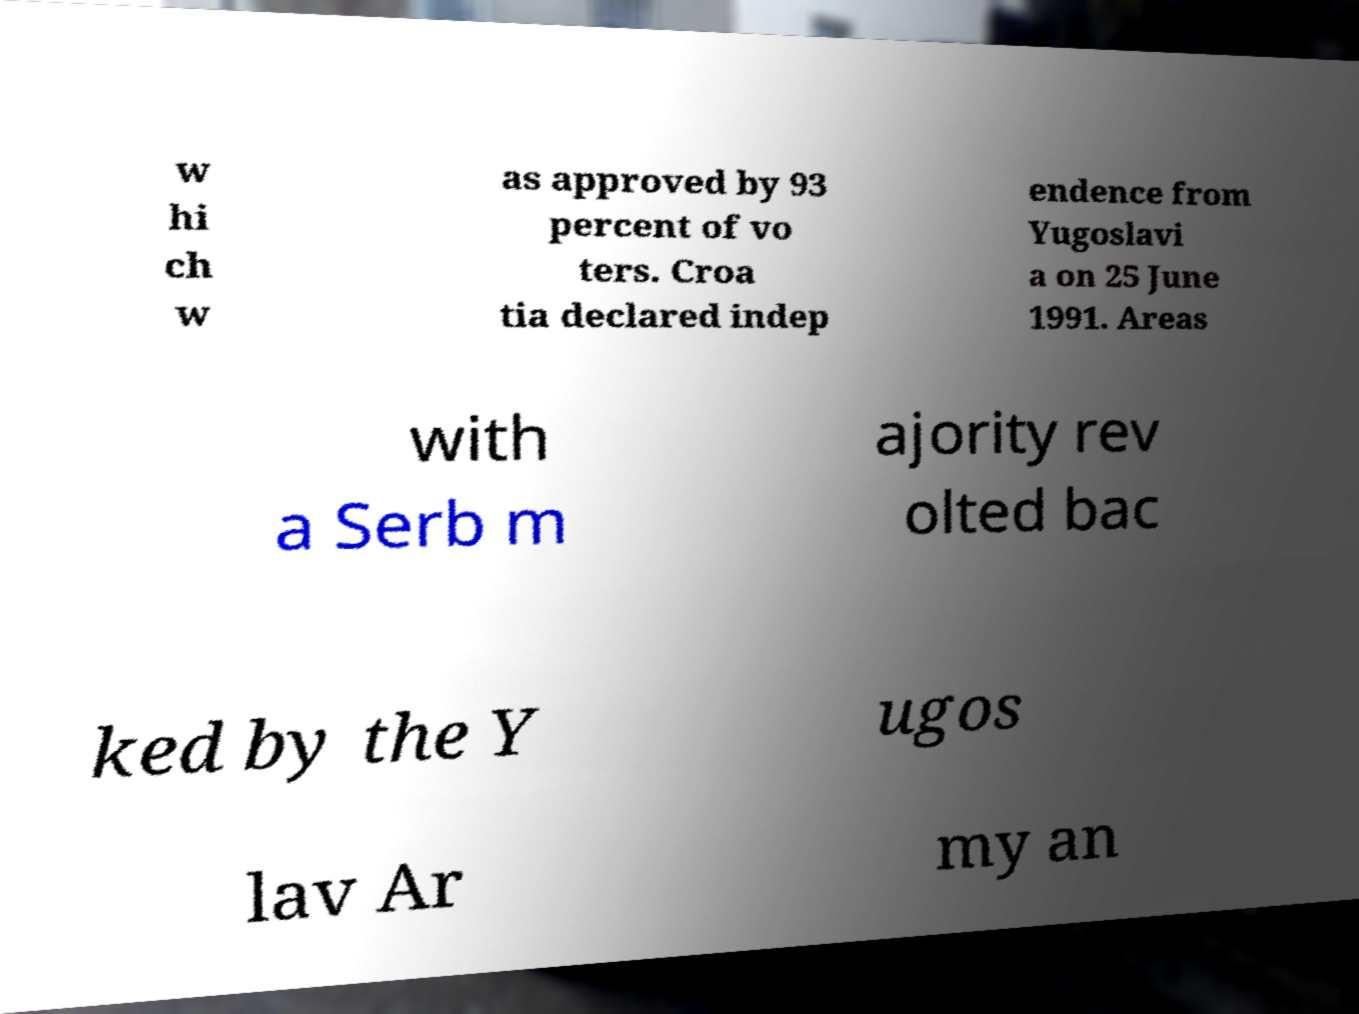I need the written content from this picture converted into text. Can you do that? w hi ch w as approved by 93 percent of vo ters. Croa tia declared indep endence from Yugoslavi a on 25 June 1991. Areas with a Serb m ajority rev olted bac ked by the Y ugos lav Ar my an 